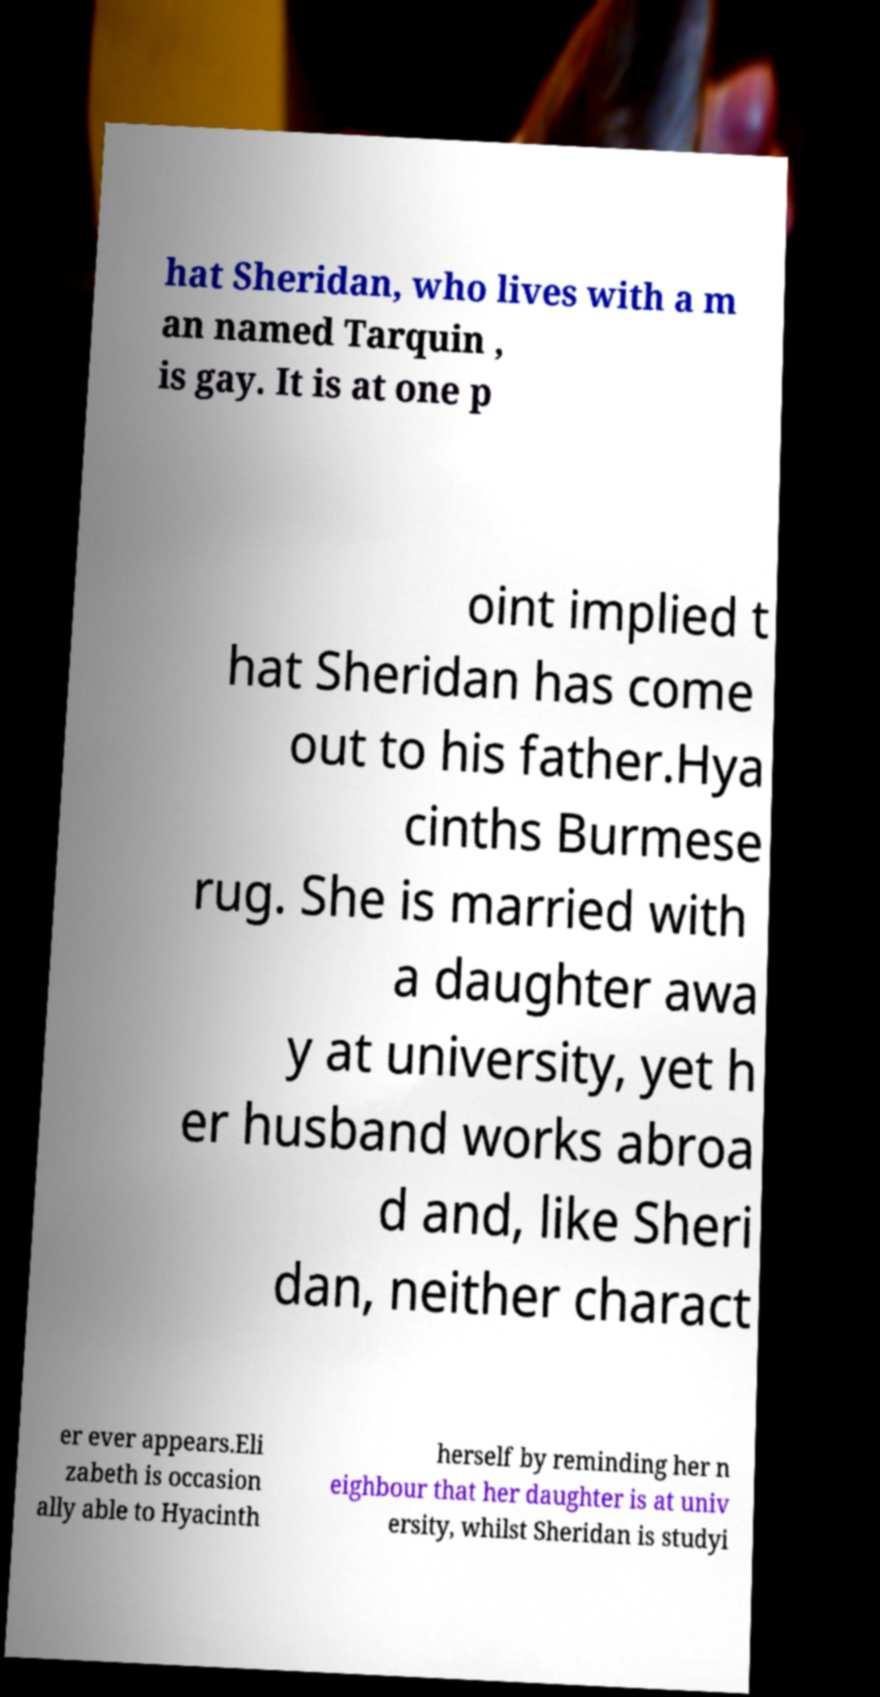Could you extract and type out the text from this image? hat Sheridan, who lives with a m an named Tarquin , is gay. It is at one p oint implied t hat Sheridan has come out to his father.Hya cinths Burmese rug. She is married with a daughter awa y at university, yet h er husband works abroa d and, like Sheri dan, neither charact er ever appears.Eli zabeth is occasion ally able to Hyacinth herself by reminding her n eighbour that her daughter is at univ ersity, whilst Sheridan is studyi 